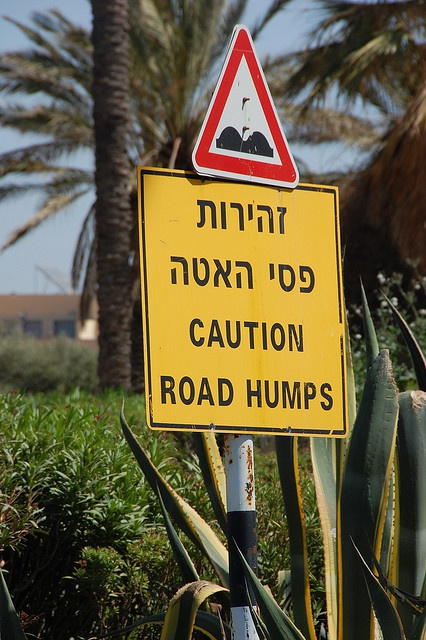Describe the objects in this image and their specific colors. I can see various objects in this image with different colors. 